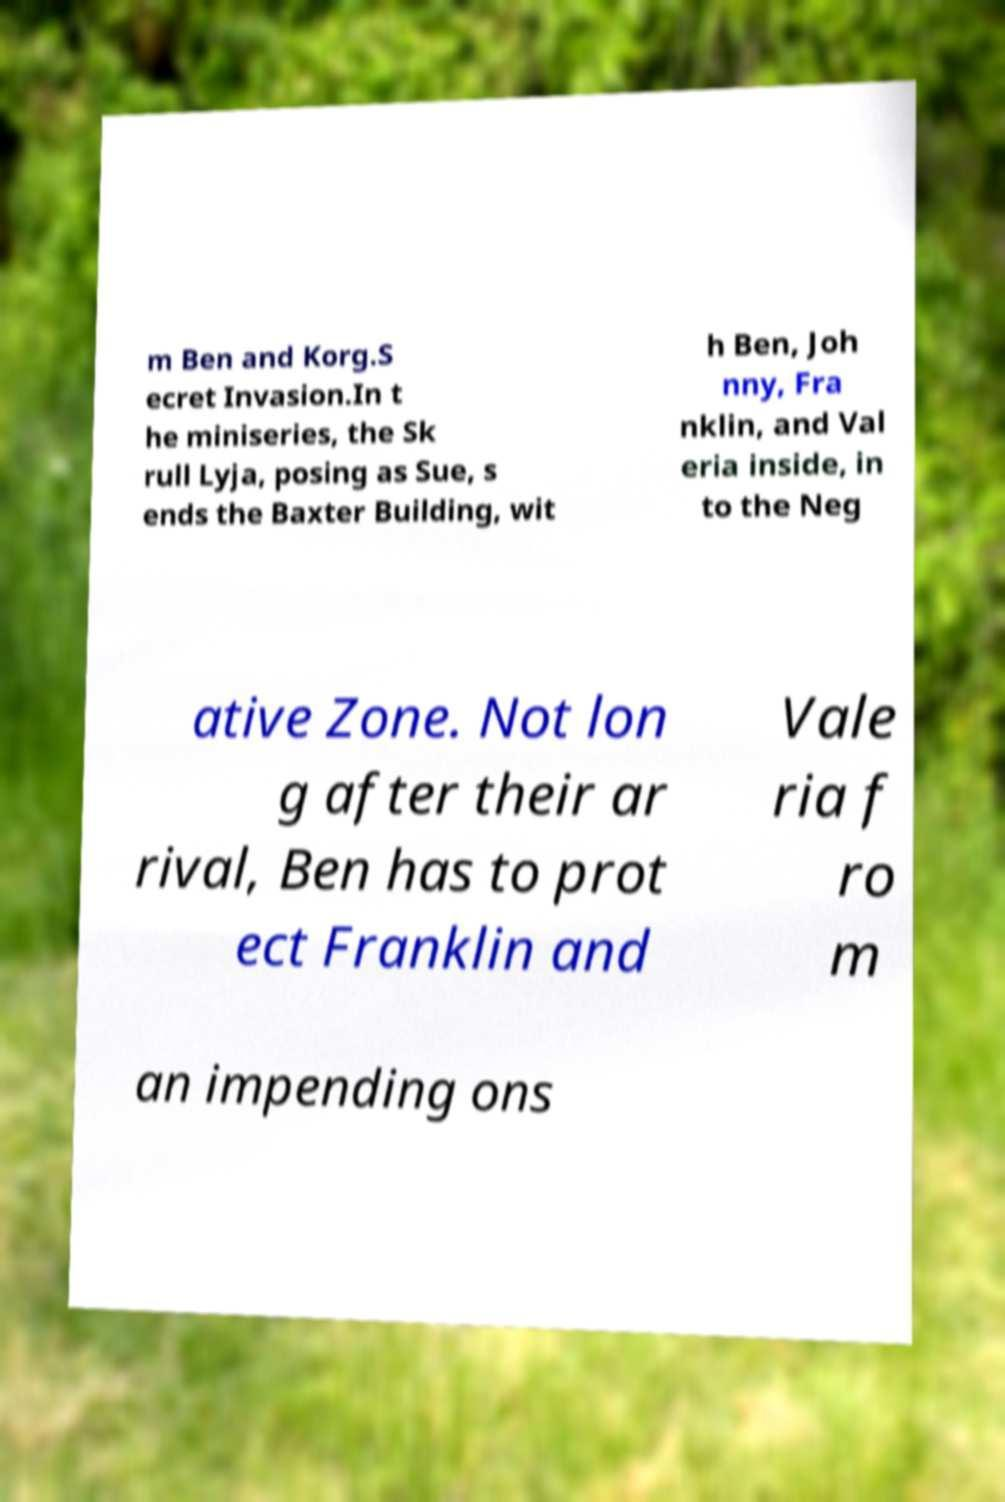There's text embedded in this image that I need extracted. Can you transcribe it verbatim? m Ben and Korg.S ecret Invasion.In t he miniseries, the Sk rull Lyja, posing as Sue, s ends the Baxter Building, wit h Ben, Joh nny, Fra nklin, and Val eria inside, in to the Neg ative Zone. Not lon g after their ar rival, Ben has to prot ect Franklin and Vale ria f ro m an impending ons 